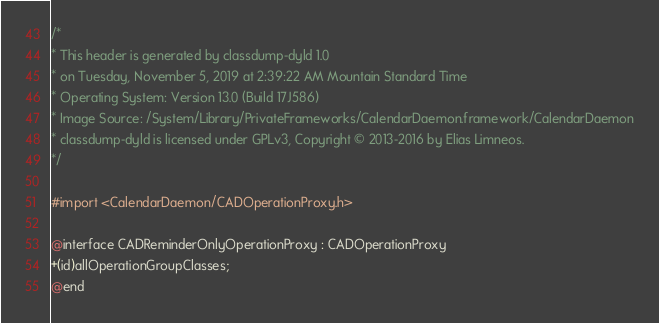<code> <loc_0><loc_0><loc_500><loc_500><_C_>/*
* This header is generated by classdump-dyld 1.0
* on Tuesday, November 5, 2019 at 2:39:22 AM Mountain Standard Time
* Operating System: Version 13.0 (Build 17J586)
* Image Source: /System/Library/PrivateFrameworks/CalendarDaemon.framework/CalendarDaemon
* classdump-dyld is licensed under GPLv3, Copyright © 2013-2016 by Elias Limneos.
*/

#import <CalendarDaemon/CADOperationProxy.h>

@interface CADReminderOnlyOperationProxy : CADOperationProxy
+(id)allOperationGroupClasses;
@end

</code> 